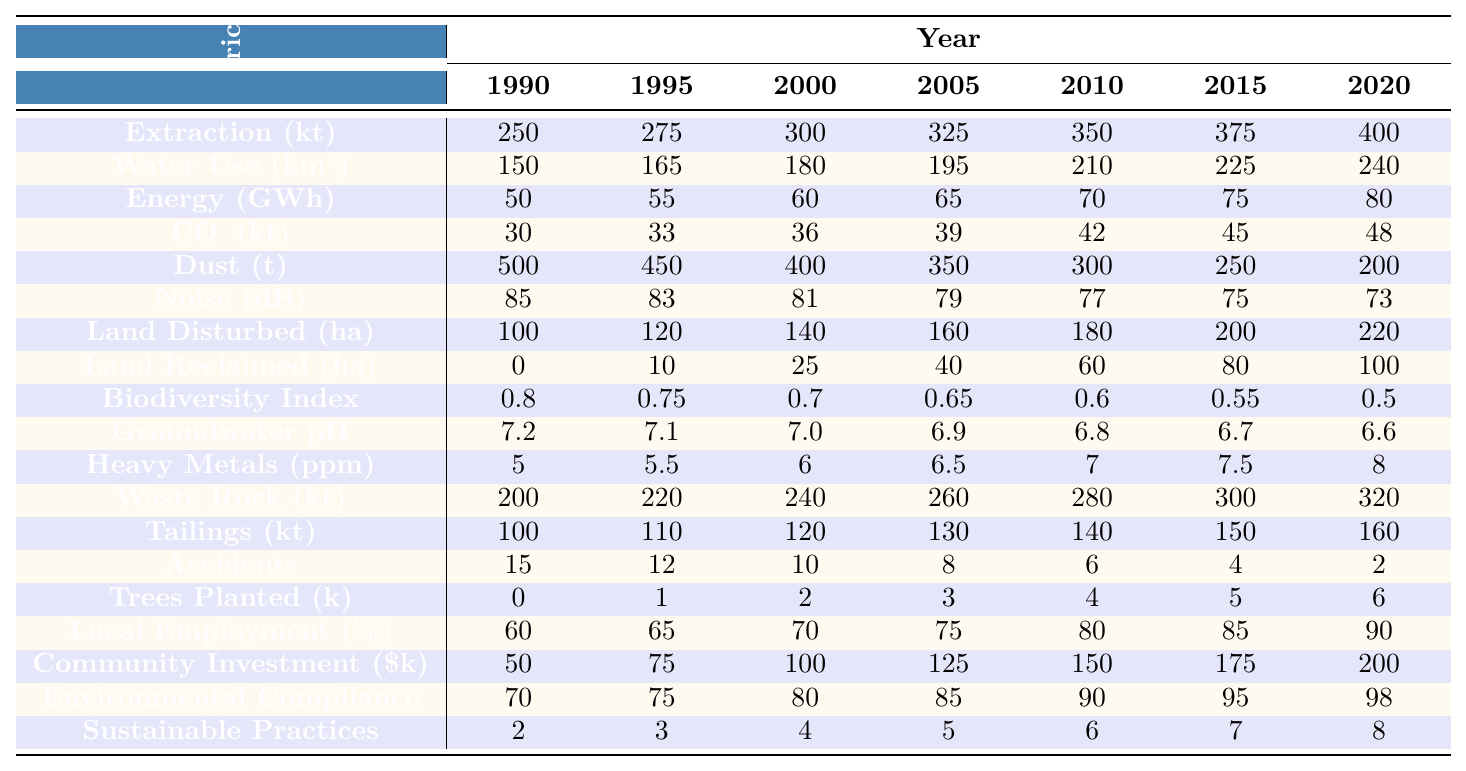What was the annual extraction volume in 2000? In the table, I can find the row corresponding to the annual extraction volume and the column for the year 2000. The value listed is 300,000 tons.
Answer: 300000 tons How much water was consumed in 1995? I can look at the row for water consumption and find the 1995 column, which shows a value of 165,000 cubic meters.
Answer: 165000 cubic meters What is the trend in CO2 emissions from 1990 to 2020? By examining the CO2 emissions row, I see that values increased from 30,000 tons in 1990 to 48,000 tons in 2020, indicating a rising trend over 30 years.
Answer: Increasing trend What was the average biodiversity index over the years? To calculate the average, I can sum the biodiversity index values (0.8 + 0.75 + 0.7 + 0.65 + 0.6 + 0.55 + 0.5), which equals 4.65, then divide by 7, giving an average of approximately 0.665.
Answer: 0.665 How many accidents were reported in total from 1990 to 2020? I need to sum the number of accidents reported each year (15 + 12 + 10 + 8 + 6 + 4 + 2), which equals 57 over the 30 years.
Answer: 57 In which year did the land disturbed reach its highest value? Looking at the land disturbed row, the highest value is 220 hectares in 2020, thus that is the year.
Answer: 2020 Did the amount of dust emissions decrease from 1990 to 2020? Checking the dust emissions row, I see that it started at 500 tons in 1990 and decreased to 200 tons in 2020, confirming a decrease over the years.
Answer: Yes What was the difference in water consumption between 2015 and 1990? Subtract the value of water consumption in 1990 from the value in 2015 (225,000 - 150,000 = 75,000), resulting in a difference of 75,000 cubic meters.
Answer: 75000 cubic meters Has the local employment percentage increased over the years? By looking at the local employment percentage both in 1990 (60%) and 2020 (90%), I can confirm there's an increase across the years.
Answer: Yes What was the highest noise level recorded and in what year? The highest noise level is found in the row for noise levels, set at 85 dB in the year 1990, which is the maximum value.
Answer: 85 dB in 1990 